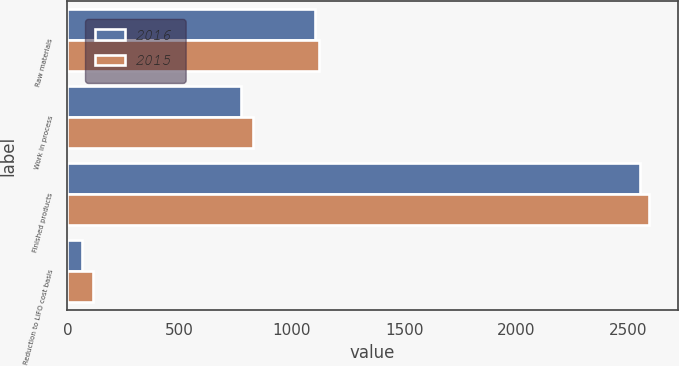<chart> <loc_0><loc_0><loc_500><loc_500><stacked_bar_chart><ecel><fcel>Raw materials<fcel>Work in process<fcel>Finished products<fcel>Reduction to LIFO cost basis<nl><fcel>2016<fcel>1104<fcel>775<fcel>2552<fcel>65<nl><fcel>2015<fcel>1120<fcel>826<fcel>2590<fcel>116<nl></chart> 